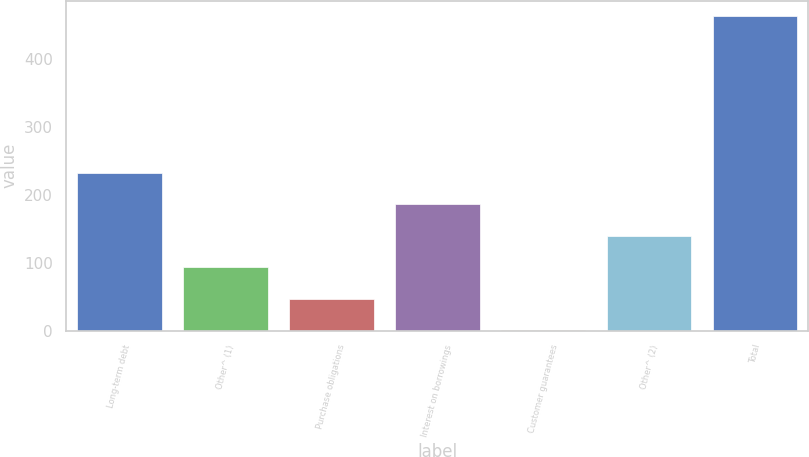Convert chart. <chart><loc_0><loc_0><loc_500><loc_500><bar_chart><fcel>Long-term debt<fcel>Other^ (1)<fcel>Purchase obligations<fcel>Interest on borrowings<fcel>Customer guarantees<fcel>Other^ (2)<fcel>Total<nl><fcel>231.5<fcel>93.2<fcel>47.1<fcel>185.4<fcel>1<fcel>139.3<fcel>462<nl></chart> 